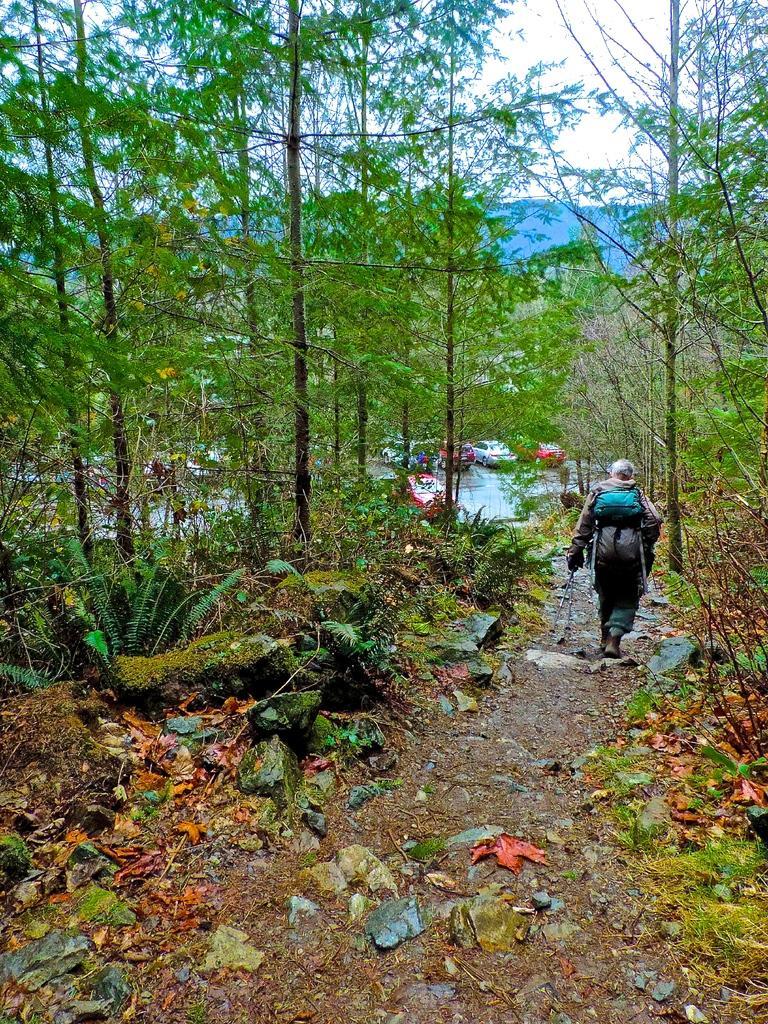Can you describe this image briefly? In this image a person is walking on the path carrying backpack. On both sides there are trees. In the background few cars are parked on the road. 